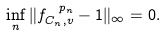Convert formula to latex. <formula><loc_0><loc_0><loc_500><loc_500>\inf _ { n } \| f _ { C _ { n } , v } ^ { \ p _ { n } } - 1 \| _ { \infty } = 0 .</formula> 